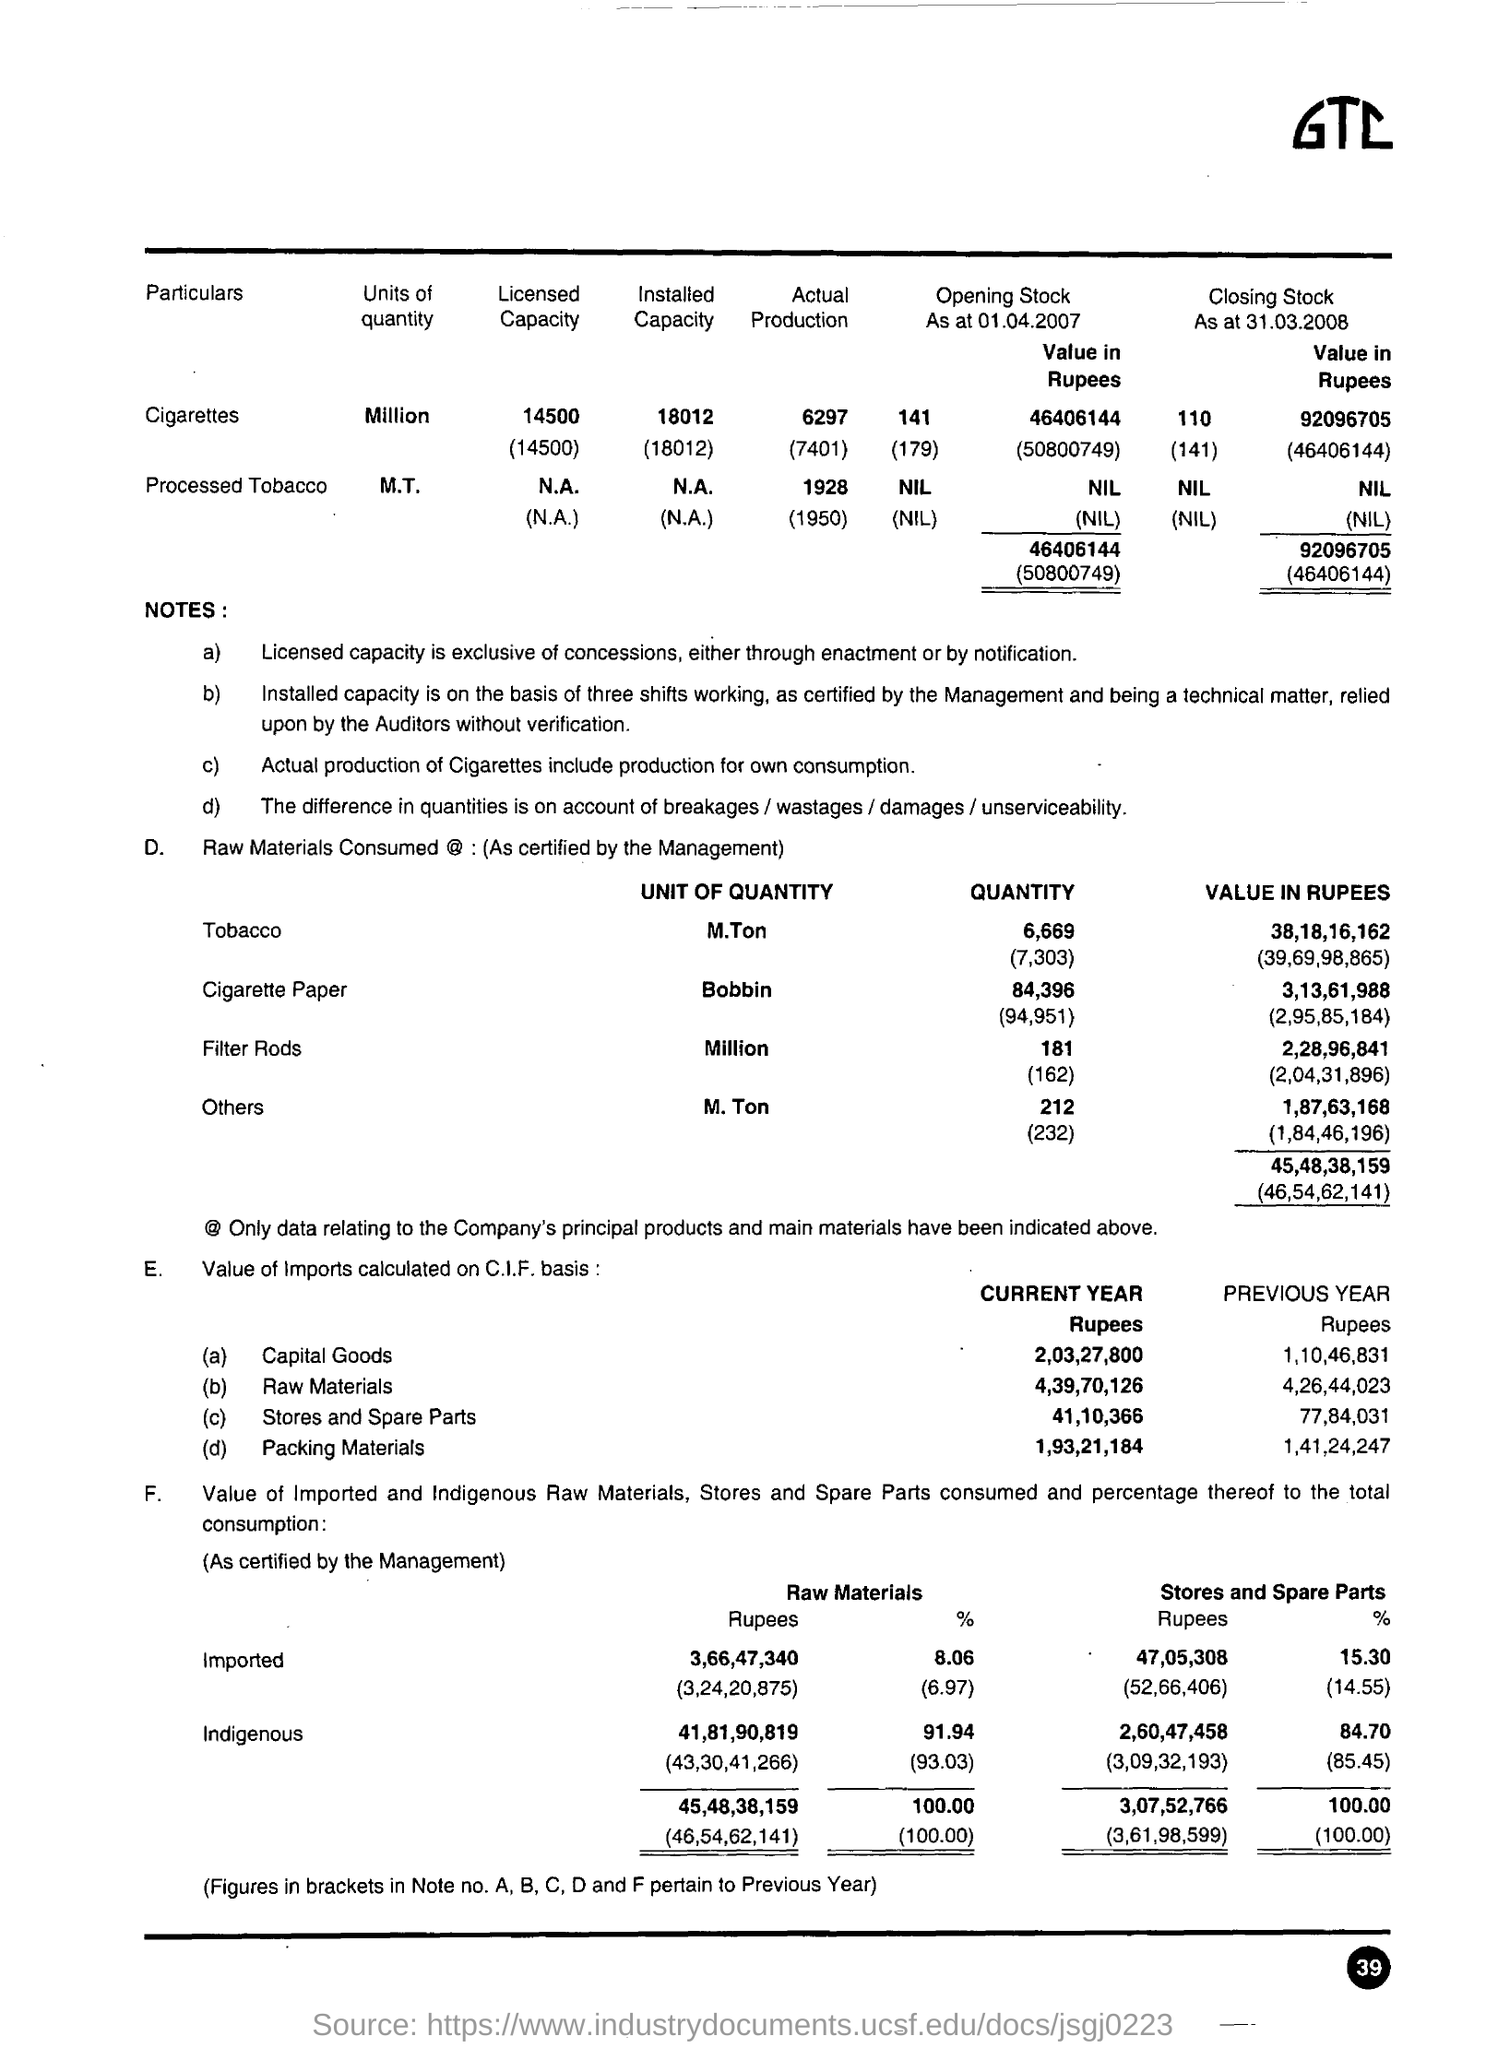Outline some significant characteristics in this image. The number written in the bottom right of the page is 39. The term "General Terms and Conditions" appears to the right of the document. The point E mentions capital goods, as mentioned in (a). 